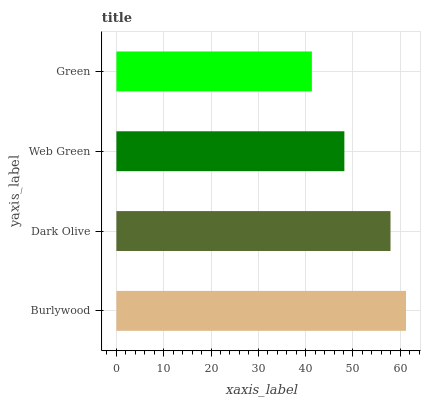Is Green the minimum?
Answer yes or no. Yes. Is Burlywood the maximum?
Answer yes or no. Yes. Is Dark Olive the minimum?
Answer yes or no. No. Is Dark Olive the maximum?
Answer yes or no. No. Is Burlywood greater than Dark Olive?
Answer yes or no. Yes. Is Dark Olive less than Burlywood?
Answer yes or no. Yes. Is Dark Olive greater than Burlywood?
Answer yes or no. No. Is Burlywood less than Dark Olive?
Answer yes or no. No. Is Dark Olive the high median?
Answer yes or no. Yes. Is Web Green the low median?
Answer yes or no. Yes. Is Web Green the high median?
Answer yes or no. No. Is Dark Olive the low median?
Answer yes or no. No. 